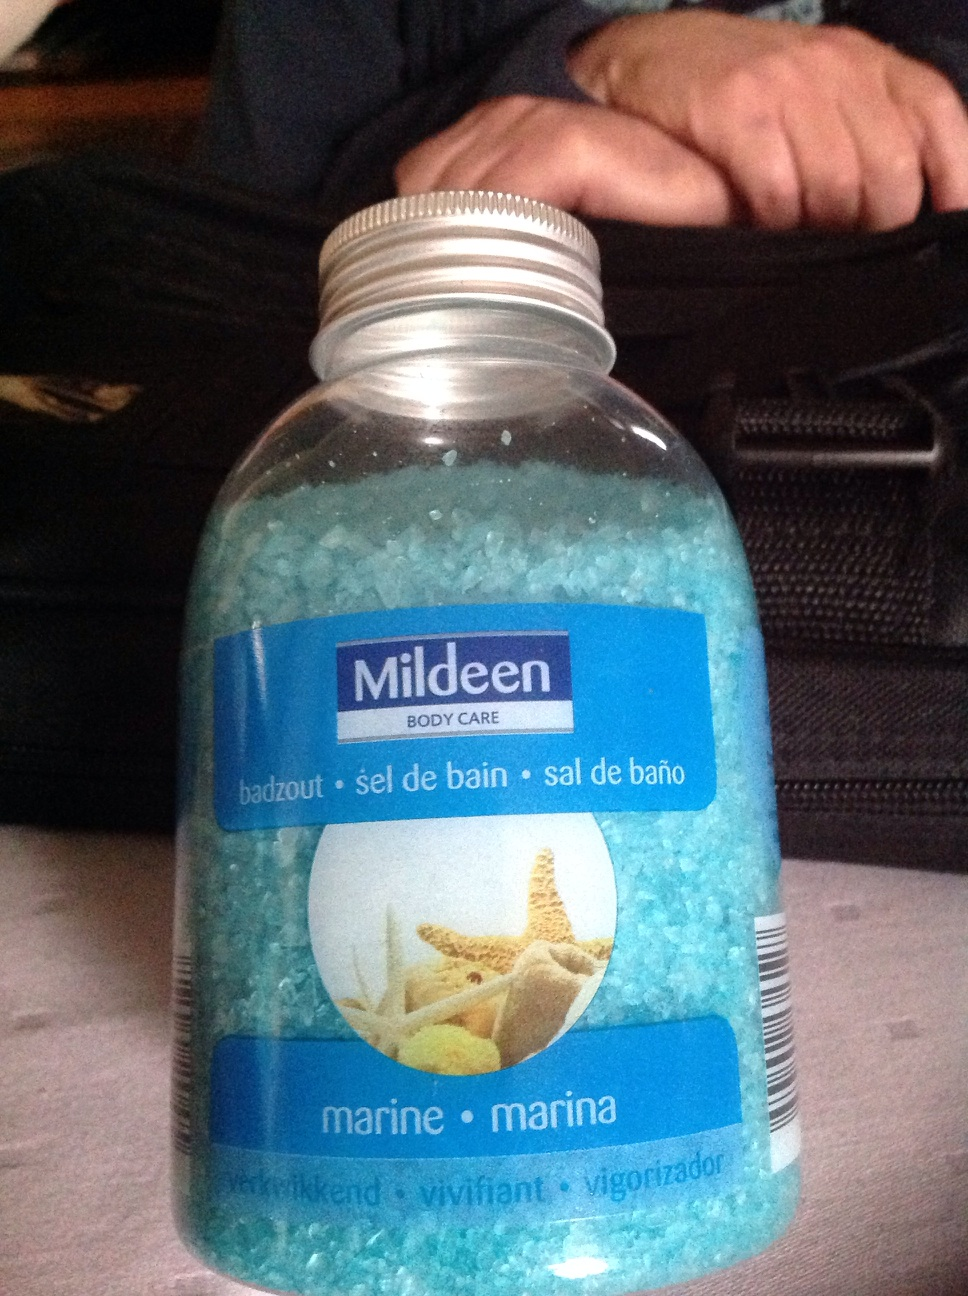What are the benefits of using this type of bath salt? Bath salts like the Mildeen marine salts are known for their therapeutic properties, such as relieving muscle tension, promoting relaxation, and improving skin hydration. They are often infused with essential oils and minerals that help in detoxifying and revitalizing the skin. 